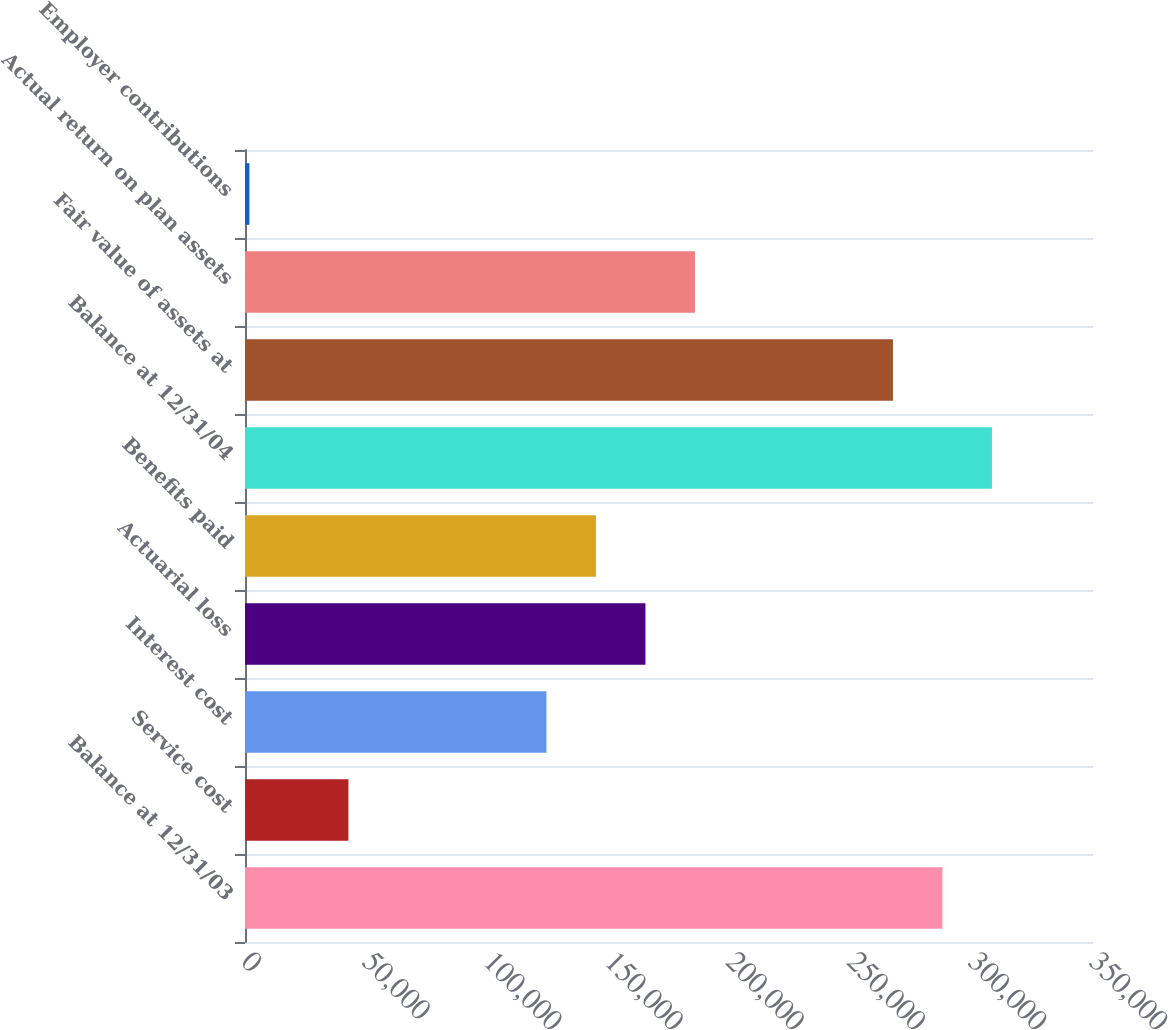Convert chart. <chart><loc_0><loc_0><loc_500><loc_500><bar_chart><fcel>Balance at 12/31/03<fcel>Service cost<fcel>Interest cost<fcel>Actuarial loss<fcel>Benefits paid<fcel>Balance at 12/31/04<fcel>Fair value of assets at<fcel>Actual return on plan assets<fcel>Employer contributions<nl><fcel>287871<fcel>42687<fcel>124415<fcel>165279<fcel>144847<fcel>308303<fcel>267439<fcel>185711<fcel>1823<nl></chart> 